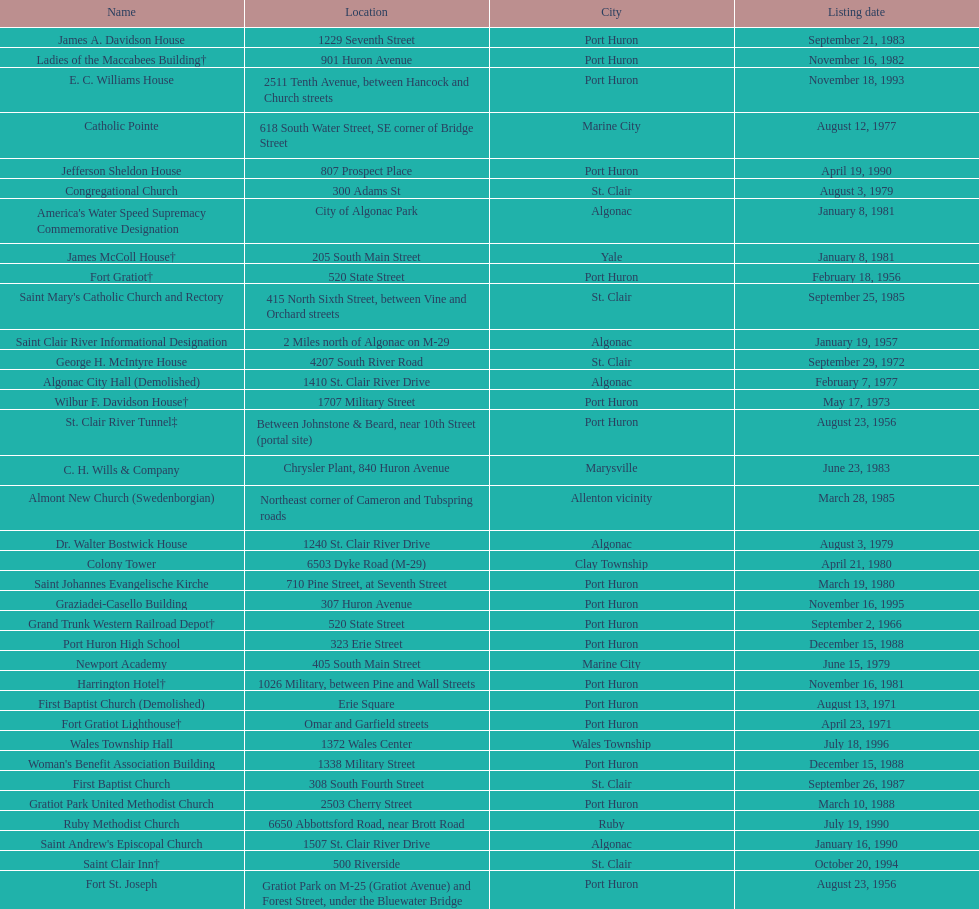Which city is home to the greatest number of historic sites, existing or demolished? Port Huron. 